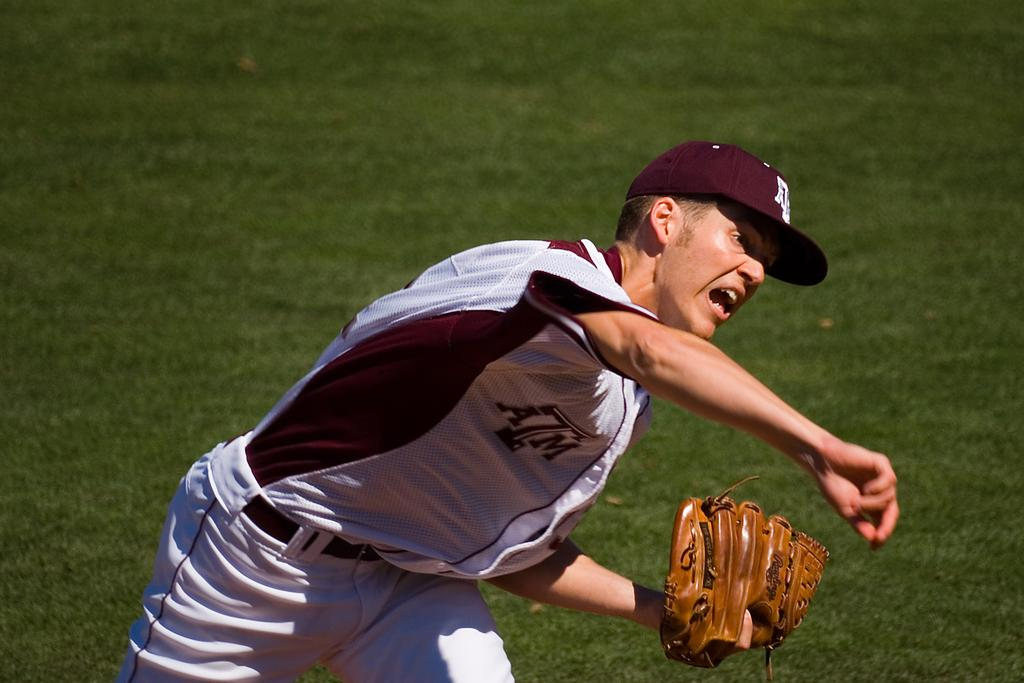<image>
Relay a brief, clear account of the picture shown. A man, wearing a jersey with the letters ATM on it, has thrown a baseball pitch. 